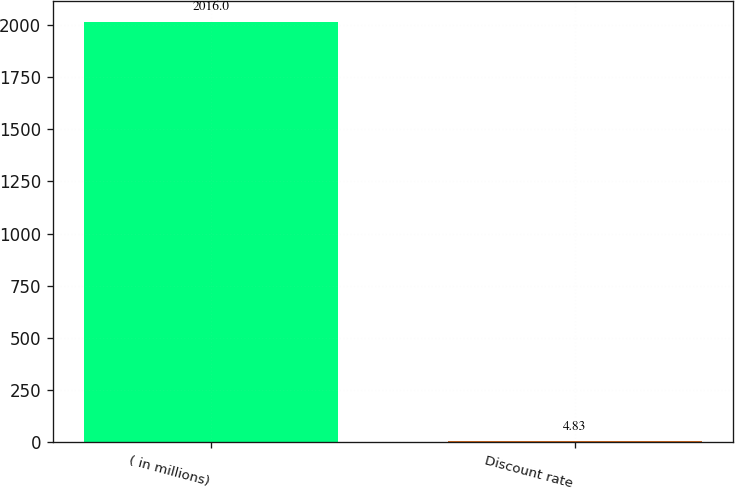Convert chart. <chart><loc_0><loc_0><loc_500><loc_500><bar_chart><fcel>( in millions)<fcel>Discount rate<nl><fcel>2016<fcel>4.83<nl></chart> 